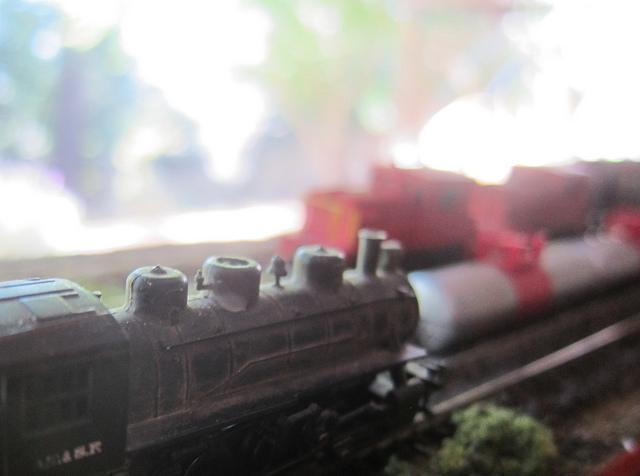How many trains are there?
Give a very brief answer. 2. 